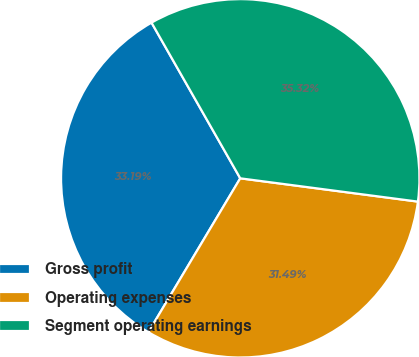Convert chart to OTSL. <chart><loc_0><loc_0><loc_500><loc_500><pie_chart><fcel>Gross profit<fcel>Operating expenses<fcel>Segment operating earnings<nl><fcel>33.19%<fcel>31.49%<fcel>35.32%<nl></chart> 